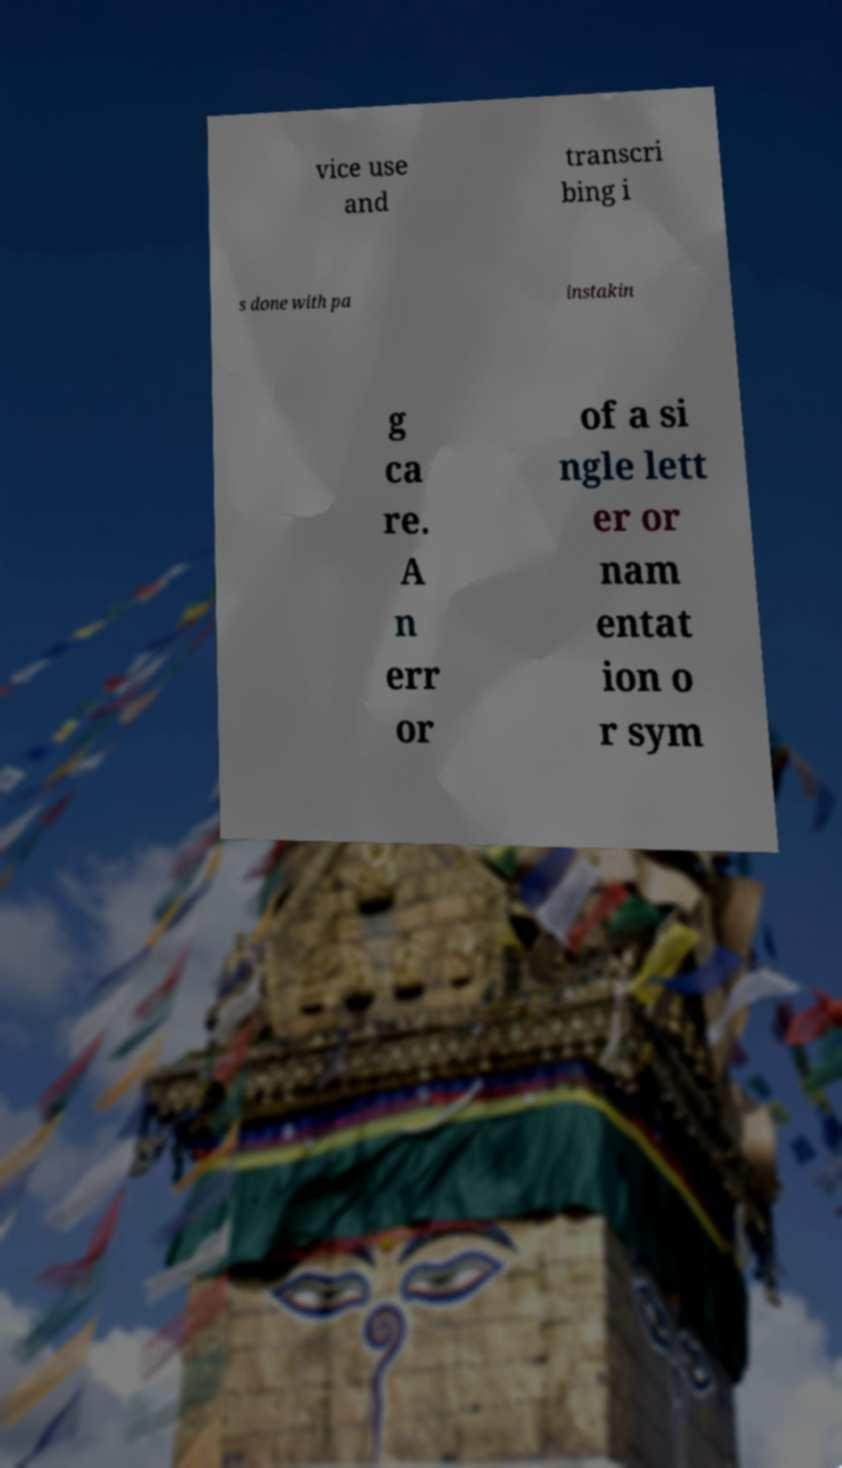Could you extract and type out the text from this image? vice use and transcri bing i s done with pa instakin g ca re. A n err or of a si ngle lett er or nam entat ion o r sym 